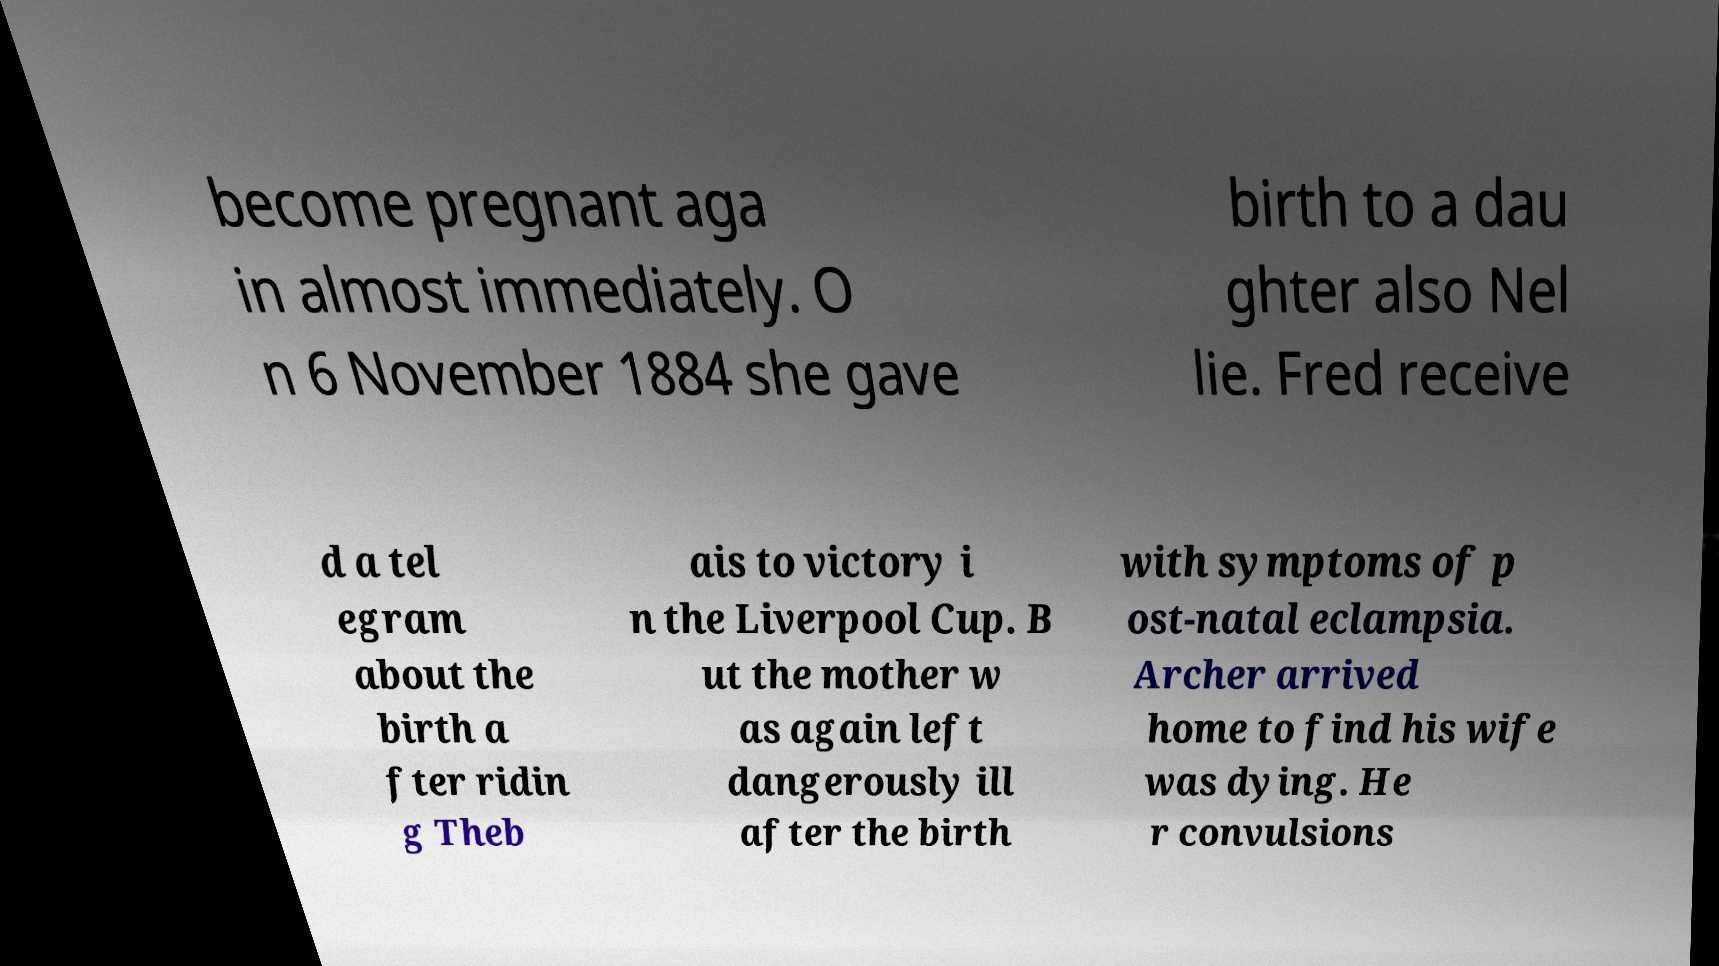Please identify and transcribe the text found in this image. become pregnant aga in almost immediately. O n 6 November 1884 she gave birth to a dau ghter also Nel lie. Fred receive d a tel egram about the birth a fter ridin g Theb ais to victory i n the Liverpool Cup. B ut the mother w as again left dangerously ill after the birth with symptoms of p ost-natal eclampsia. Archer arrived home to find his wife was dying. He r convulsions 